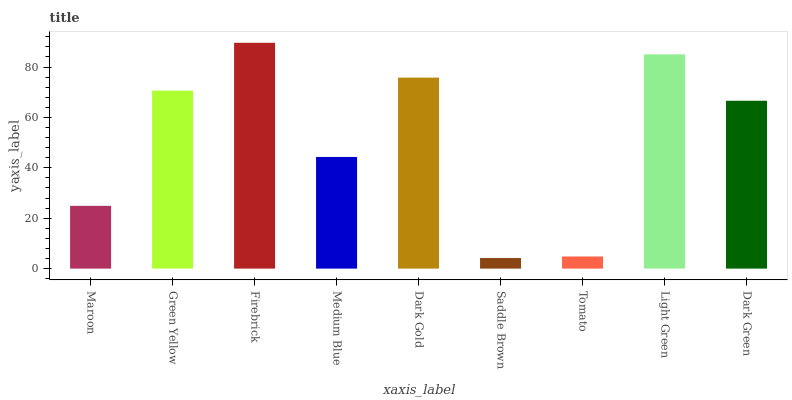Is Saddle Brown the minimum?
Answer yes or no. Yes. Is Firebrick the maximum?
Answer yes or no. Yes. Is Green Yellow the minimum?
Answer yes or no. No. Is Green Yellow the maximum?
Answer yes or no. No. Is Green Yellow greater than Maroon?
Answer yes or no. Yes. Is Maroon less than Green Yellow?
Answer yes or no. Yes. Is Maroon greater than Green Yellow?
Answer yes or no. No. Is Green Yellow less than Maroon?
Answer yes or no. No. Is Dark Green the high median?
Answer yes or no. Yes. Is Dark Green the low median?
Answer yes or no. Yes. Is Saddle Brown the high median?
Answer yes or no. No. Is Tomato the low median?
Answer yes or no. No. 